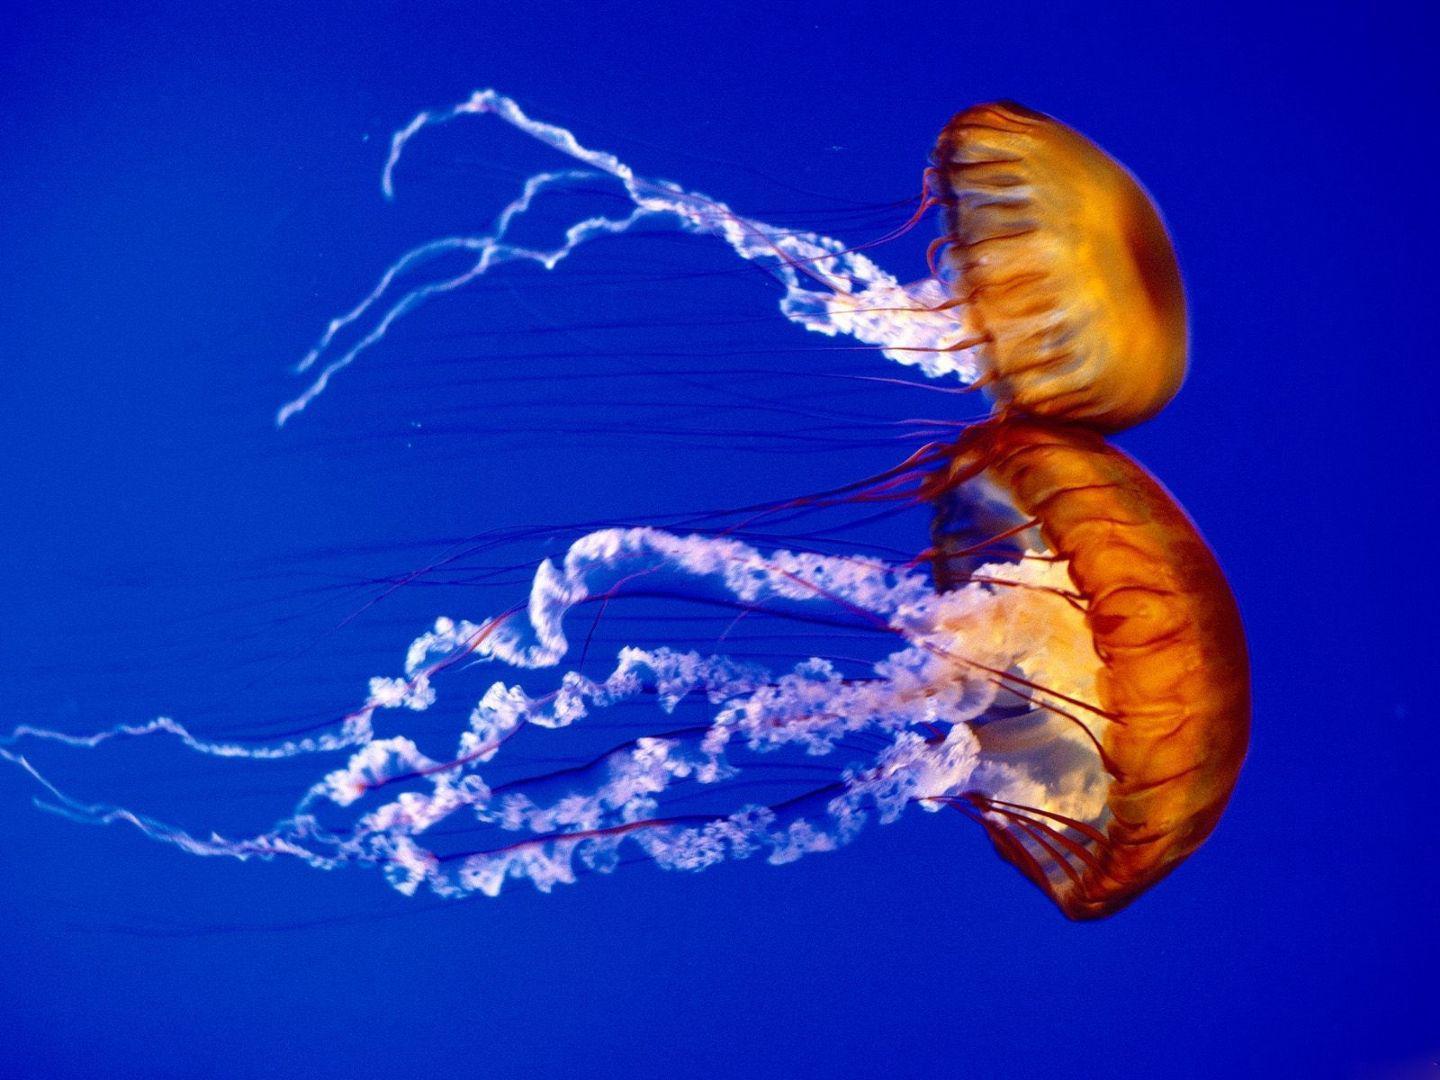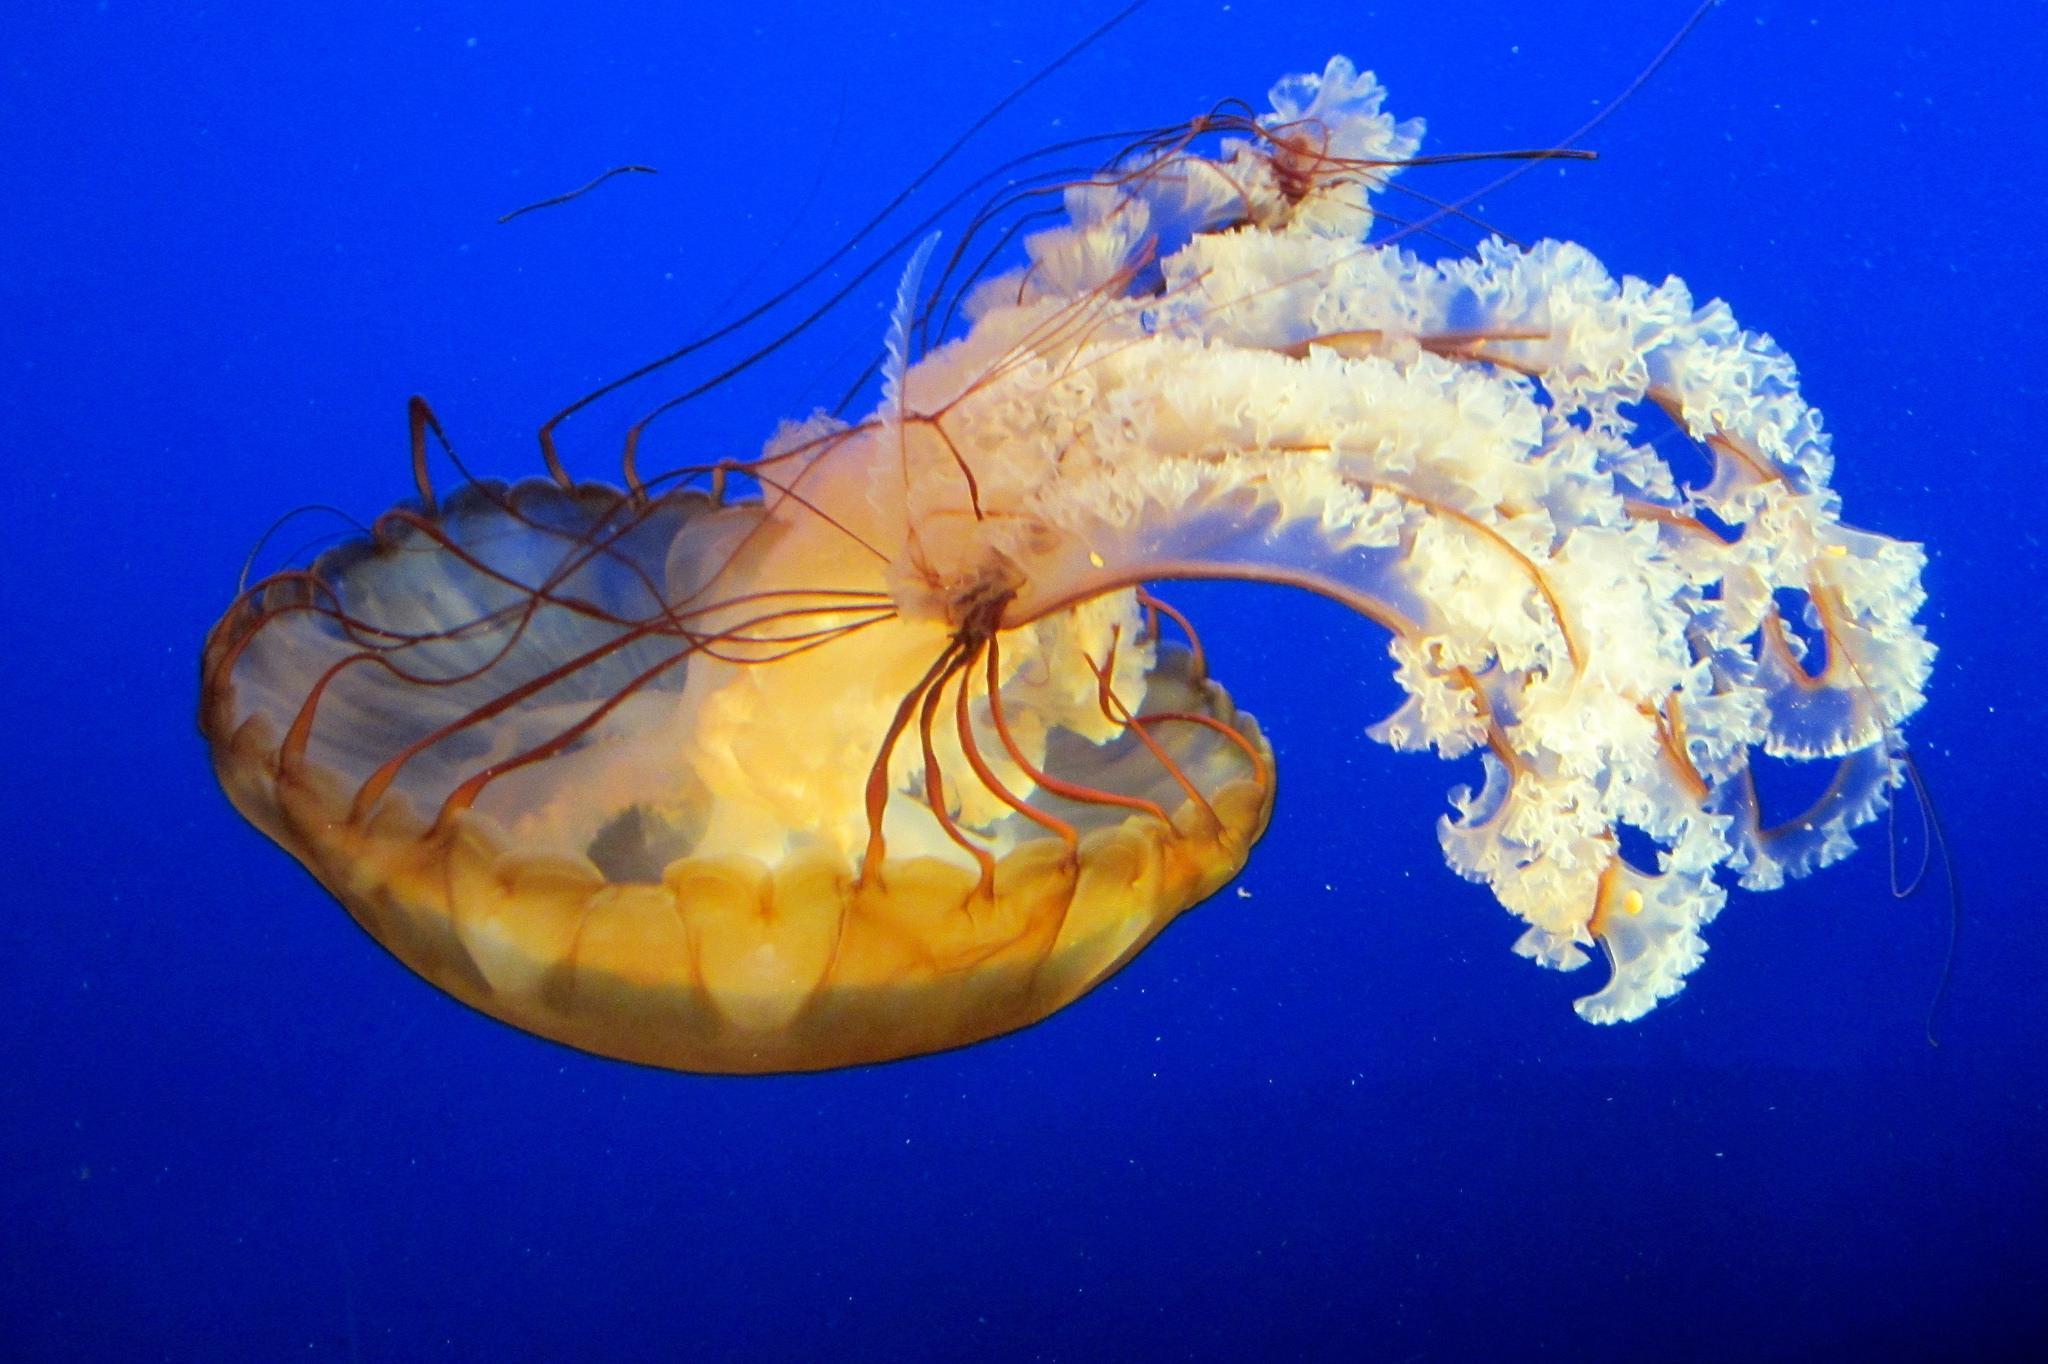The first image is the image on the left, the second image is the image on the right. For the images shown, is this caption "There are 3 jellyfish." true? Answer yes or no. Yes. 